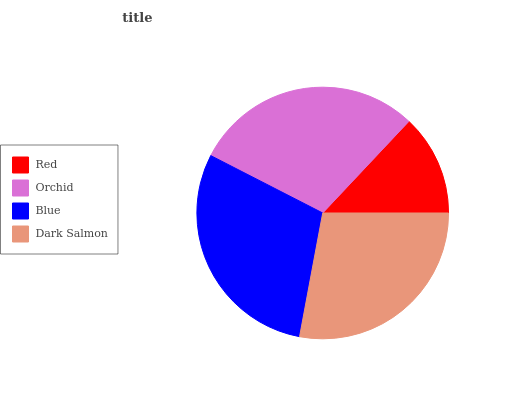Is Red the minimum?
Answer yes or no. Yes. Is Blue the maximum?
Answer yes or no. Yes. Is Orchid the minimum?
Answer yes or no. No. Is Orchid the maximum?
Answer yes or no. No. Is Orchid greater than Red?
Answer yes or no. Yes. Is Red less than Orchid?
Answer yes or no. Yes. Is Red greater than Orchid?
Answer yes or no. No. Is Orchid less than Red?
Answer yes or no. No. Is Orchid the high median?
Answer yes or no. Yes. Is Dark Salmon the low median?
Answer yes or no. Yes. Is Dark Salmon the high median?
Answer yes or no. No. Is Blue the low median?
Answer yes or no. No. 